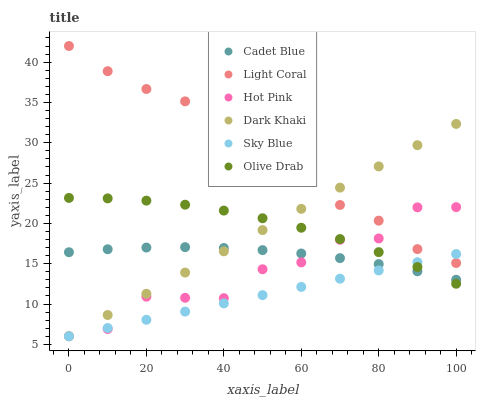Does Sky Blue have the minimum area under the curve?
Answer yes or no. Yes. Does Light Coral have the maximum area under the curve?
Answer yes or no. Yes. Does Cadet Blue have the minimum area under the curve?
Answer yes or no. No. Does Cadet Blue have the maximum area under the curve?
Answer yes or no. No. Is Sky Blue the smoothest?
Answer yes or no. Yes. Is Hot Pink the roughest?
Answer yes or no. Yes. Is Cadet Blue the smoothest?
Answer yes or no. No. Is Cadet Blue the roughest?
Answer yes or no. No. Does Dark Khaki have the lowest value?
Answer yes or no. Yes. Does Cadet Blue have the lowest value?
Answer yes or no. No. Does Light Coral have the highest value?
Answer yes or no. Yes. Does Cadet Blue have the highest value?
Answer yes or no. No. Is Cadet Blue less than Light Coral?
Answer yes or no. Yes. Is Light Coral greater than Olive Drab?
Answer yes or no. Yes. Does Sky Blue intersect Light Coral?
Answer yes or no. Yes. Is Sky Blue less than Light Coral?
Answer yes or no. No. Is Sky Blue greater than Light Coral?
Answer yes or no. No. Does Cadet Blue intersect Light Coral?
Answer yes or no. No. 